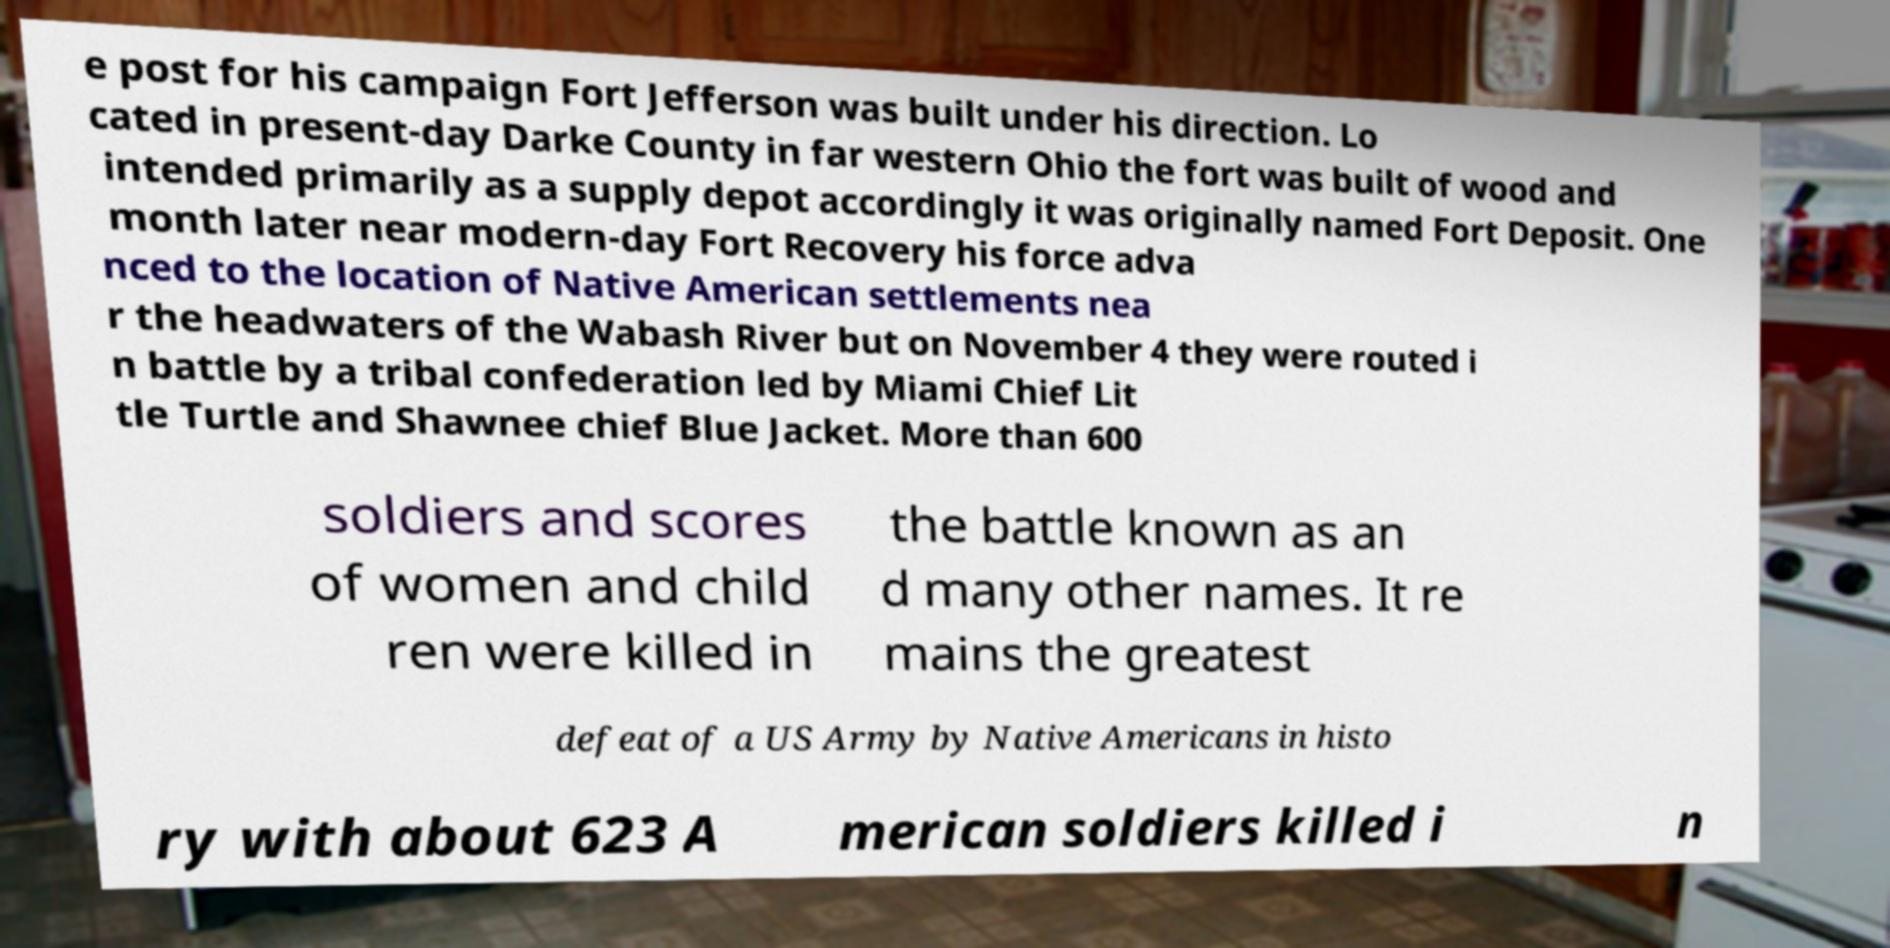Could you extract and type out the text from this image? e post for his campaign Fort Jefferson was built under his direction. Lo cated in present-day Darke County in far western Ohio the fort was built of wood and intended primarily as a supply depot accordingly it was originally named Fort Deposit. One month later near modern-day Fort Recovery his force adva nced to the location of Native American settlements nea r the headwaters of the Wabash River but on November 4 they were routed i n battle by a tribal confederation led by Miami Chief Lit tle Turtle and Shawnee chief Blue Jacket. More than 600 soldiers and scores of women and child ren were killed in the battle known as an d many other names. It re mains the greatest defeat of a US Army by Native Americans in histo ry with about 623 A merican soldiers killed i n 